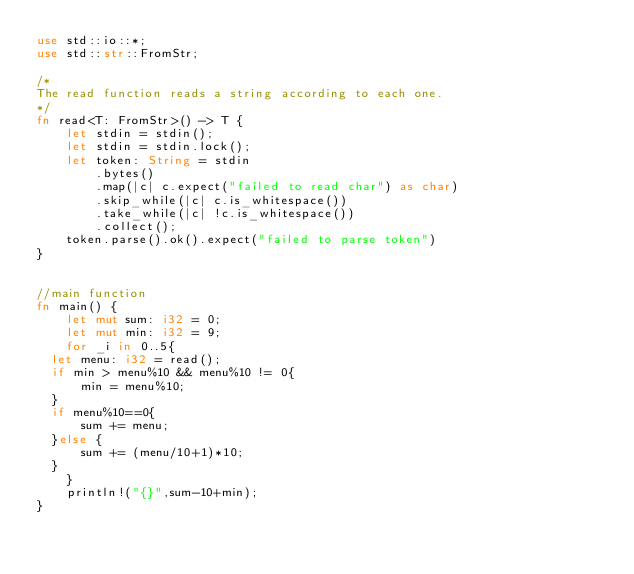Convert code to text. <code><loc_0><loc_0><loc_500><loc_500><_Rust_>use std::io::*;
use std::str::FromStr;
 
/* 
The read function reads a string according to each one. 
*/
fn read<T: FromStr>() -> T {
    let stdin = stdin();
    let stdin = stdin.lock();
    let token: String = stdin
        .bytes()
        .map(|c| c.expect("failed to read char") as char) 
        .skip_while(|c| c.is_whitespace())
        .take_while(|c| !c.is_whitespace())
        .collect();
    token.parse().ok().expect("failed to parse token")
}


//main function
fn main() {
    let mut sum: i32 = 0;
    let mut min: i32 = 9;
    for _i in 0..5{
	let menu: i32 = read();
	if min > menu%10 && menu%10 != 0{
	    min = menu%10;
	}
	if menu%10==0{
	    sum += menu;
	}else {
	    sum += (menu/10+1)*10;
	}
    }
    println!("{}",sum-10+min);
}
</code> 